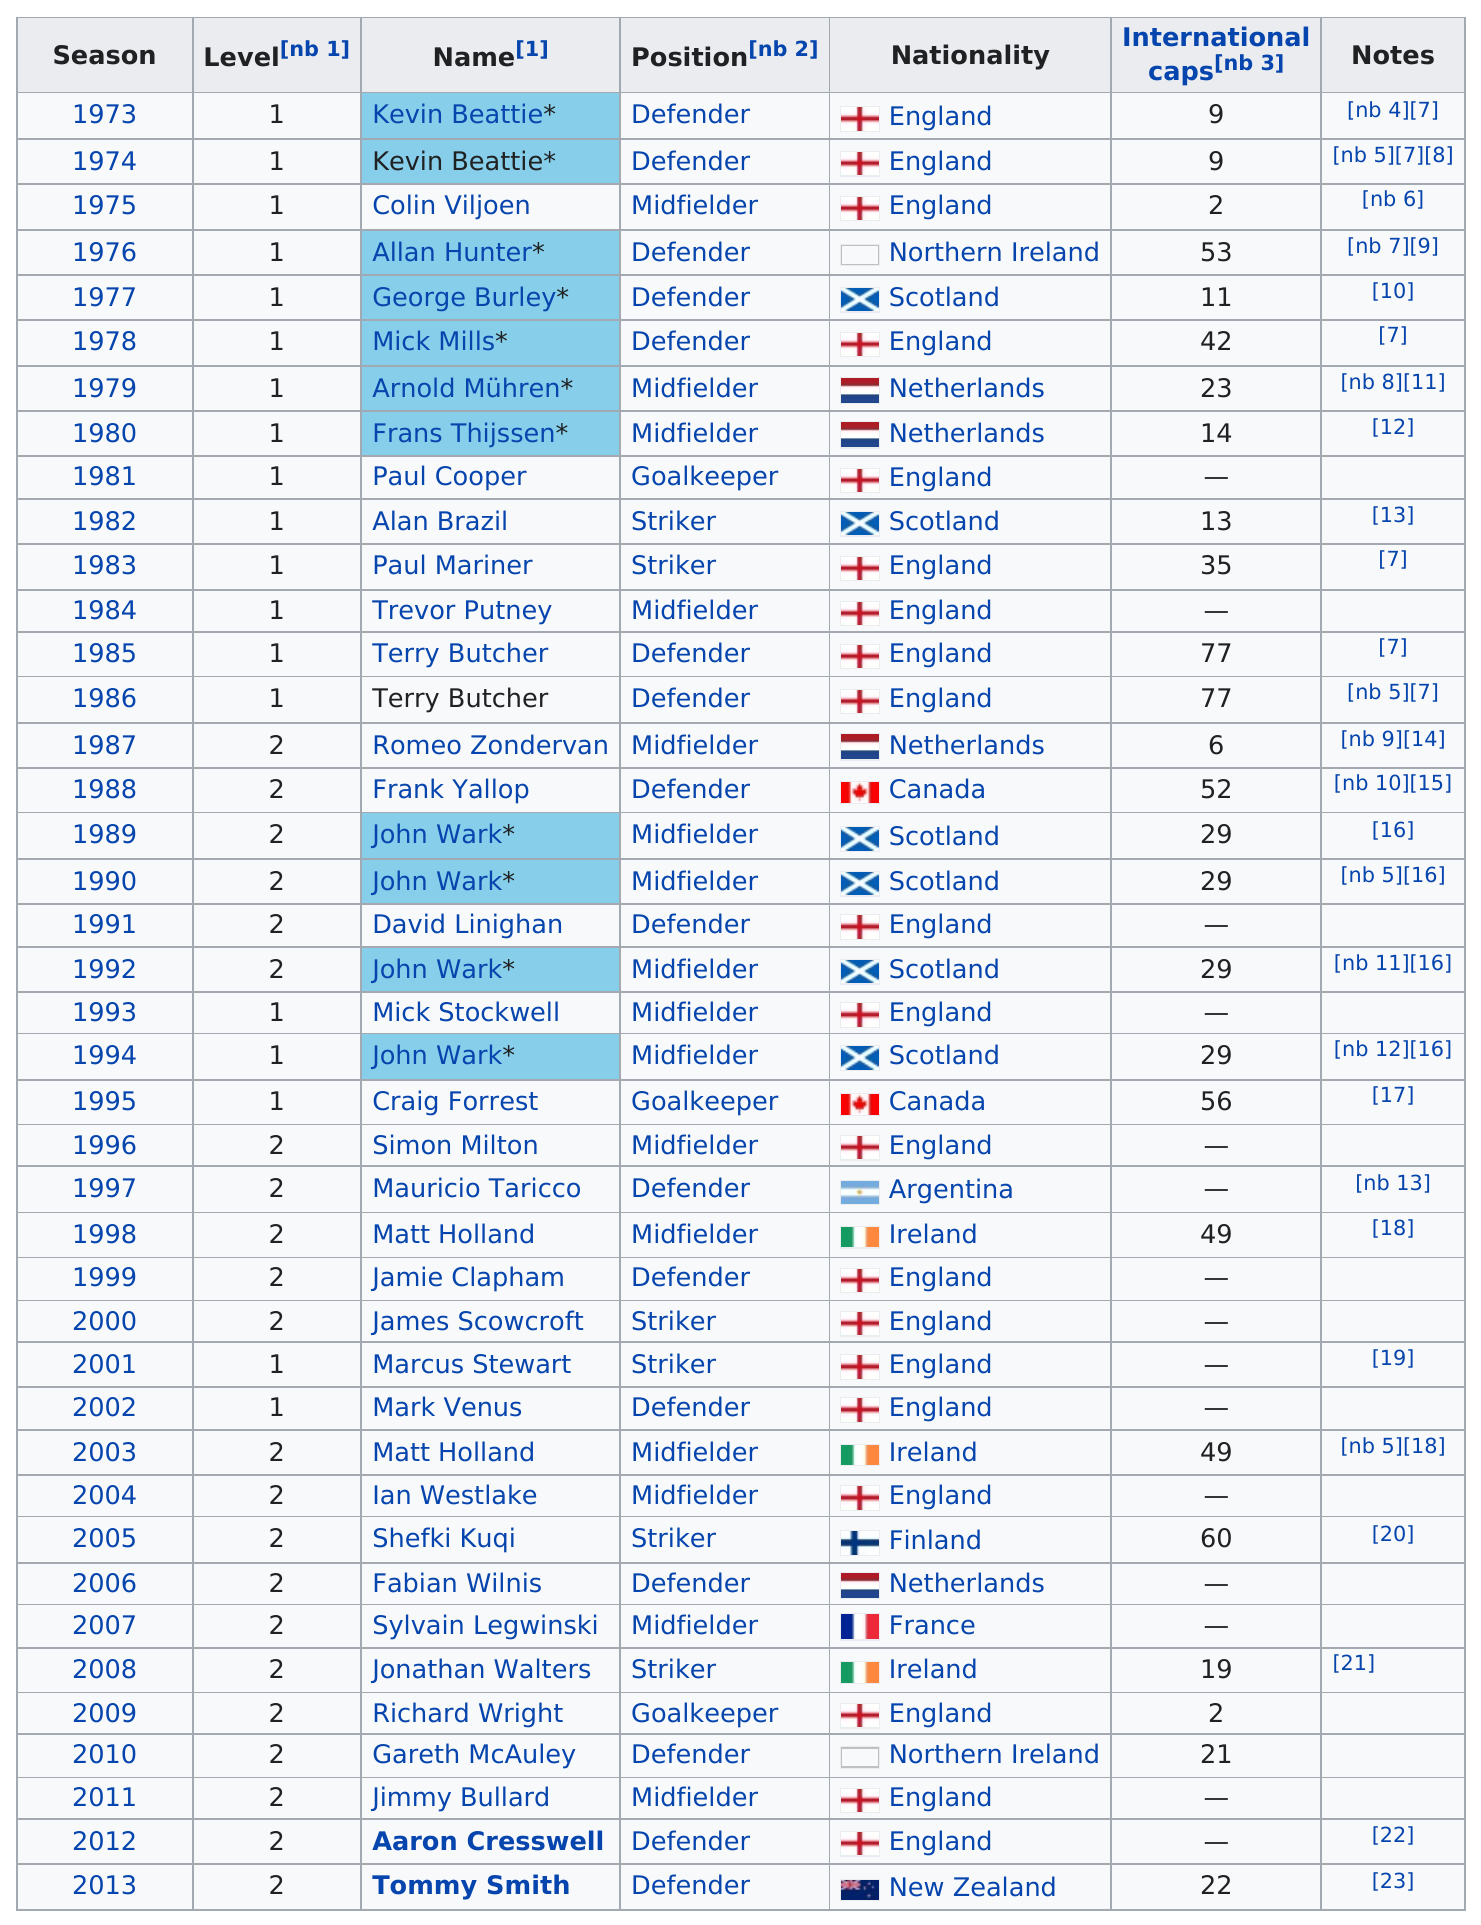Highlight a few significant elements in this photo. The season that follows 1986 is 1987. Please provide the name of the only player from New Zealand on the list. It is Tommy Smith. The last player from England to be inducted was Aaron Cresswell. Terry Butcher was awarded Player of the Year a total of two times throughout his career. Tommy Smith was the only player from New Zealand to be named Player of the Year. 